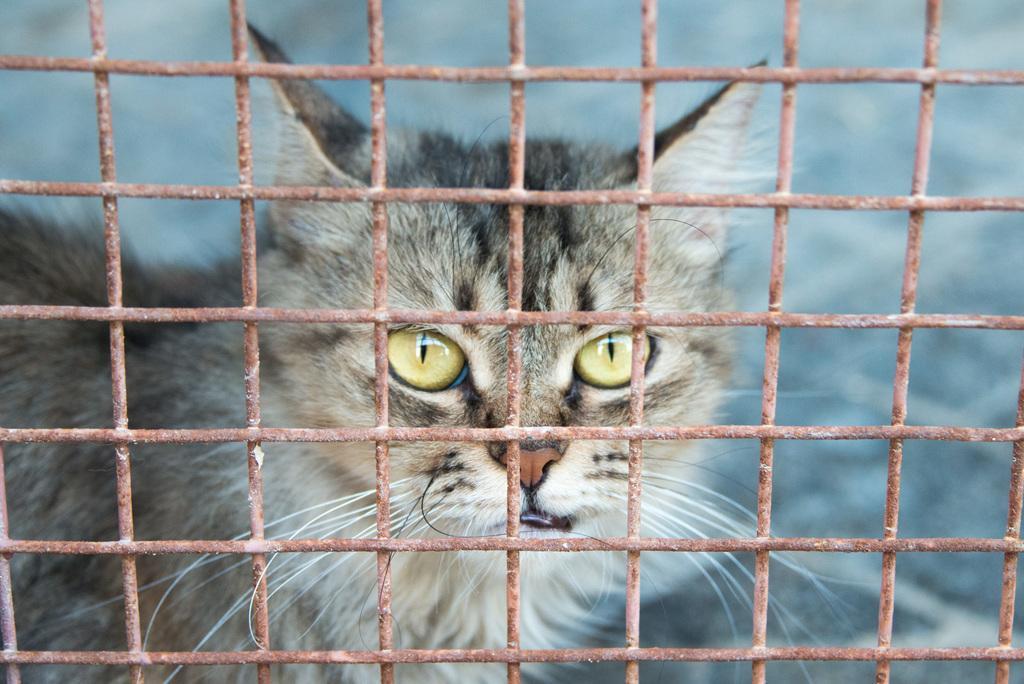Please provide a concise description of this image. This image is taken outdoors. In this image there is a mesh and behind the mesh there is a cat. 